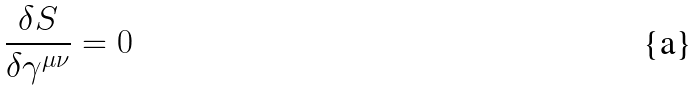Convert formula to latex. <formula><loc_0><loc_0><loc_500><loc_500>\frac { \delta S } { \delta \gamma ^ { \mu \nu } } = 0</formula> 